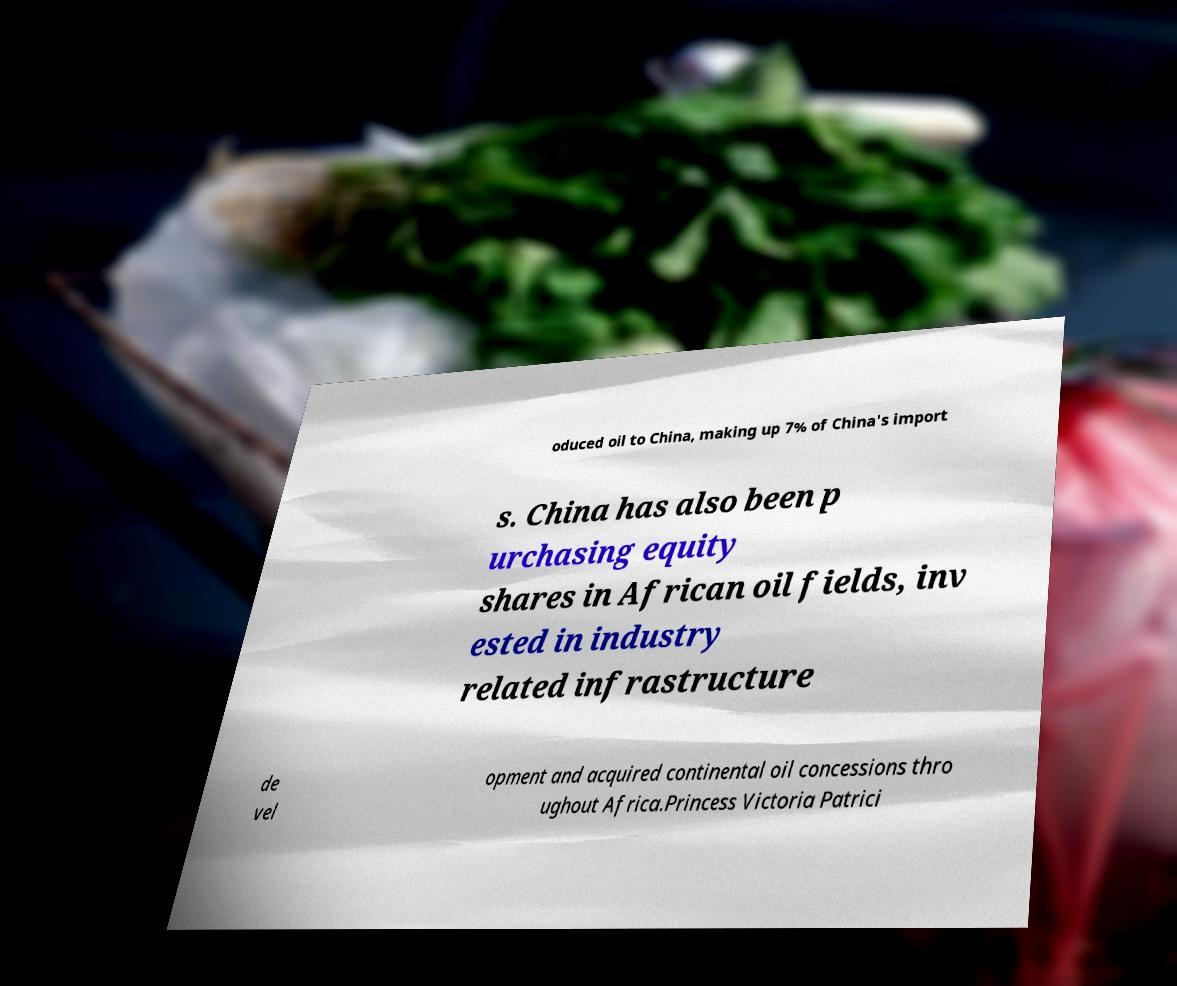There's text embedded in this image that I need extracted. Can you transcribe it verbatim? oduced oil to China, making up 7% of China's import s. China has also been p urchasing equity shares in African oil fields, inv ested in industry related infrastructure de vel opment and acquired continental oil concessions thro ughout Africa.Princess Victoria Patrici 